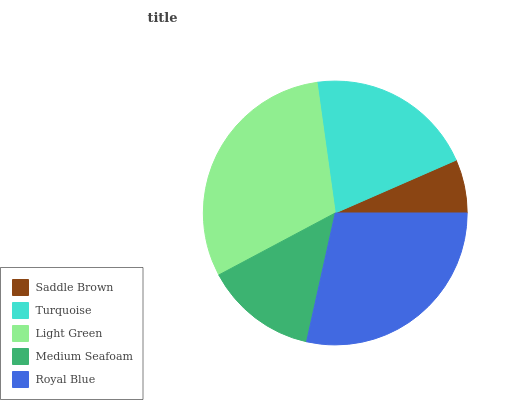Is Saddle Brown the minimum?
Answer yes or no. Yes. Is Light Green the maximum?
Answer yes or no. Yes. Is Turquoise the minimum?
Answer yes or no. No. Is Turquoise the maximum?
Answer yes or no. No. Is Turquoise greater than Saddle Brown?
Answer yes or no. Yes. Is Saddle Brown less than Turquoise?
Answer yes or no. Yes. Is Saddle Brown greater than Turquoise?
Answer yes or no. No. Is Turquoise less than Saddle Brown?
Answer yes or no. No. Is Turquoise the high median?
Answer yes or no. Yes. Is Turquoise the low median?
Answer yes or no. Yes. Is Saddle Brown the high median?
Answer yes or no. No. Is Royal Blue the low median?
Answer yes or no. No. 